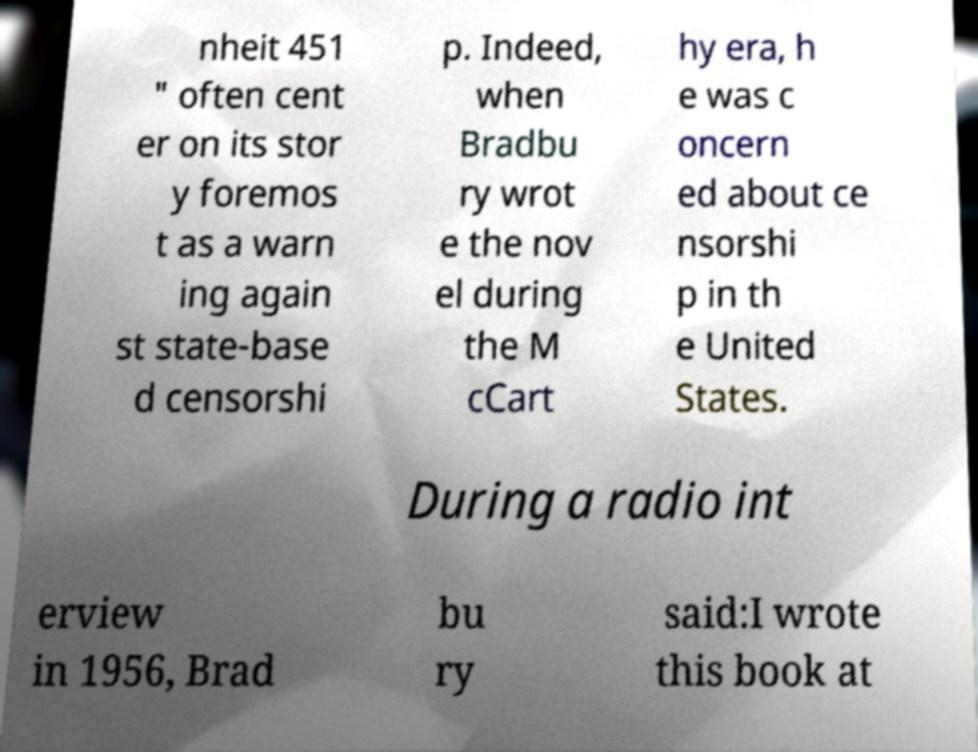Can you read and provide the text displayed in the image?This photo seems to have some interesting text. Can you extract and type it out for me? nheit 451 " often cent er on its stor y foremos t as a warn ing again st state-base d censorshi p. Indeed, when Bradbu ry wrot e the nov el during the M cCart hy era, h e was c oncern ed about ce nsorshi p in th e United States. During a radio int erview in 1956, Brad bu ry said:I wrote this book at 